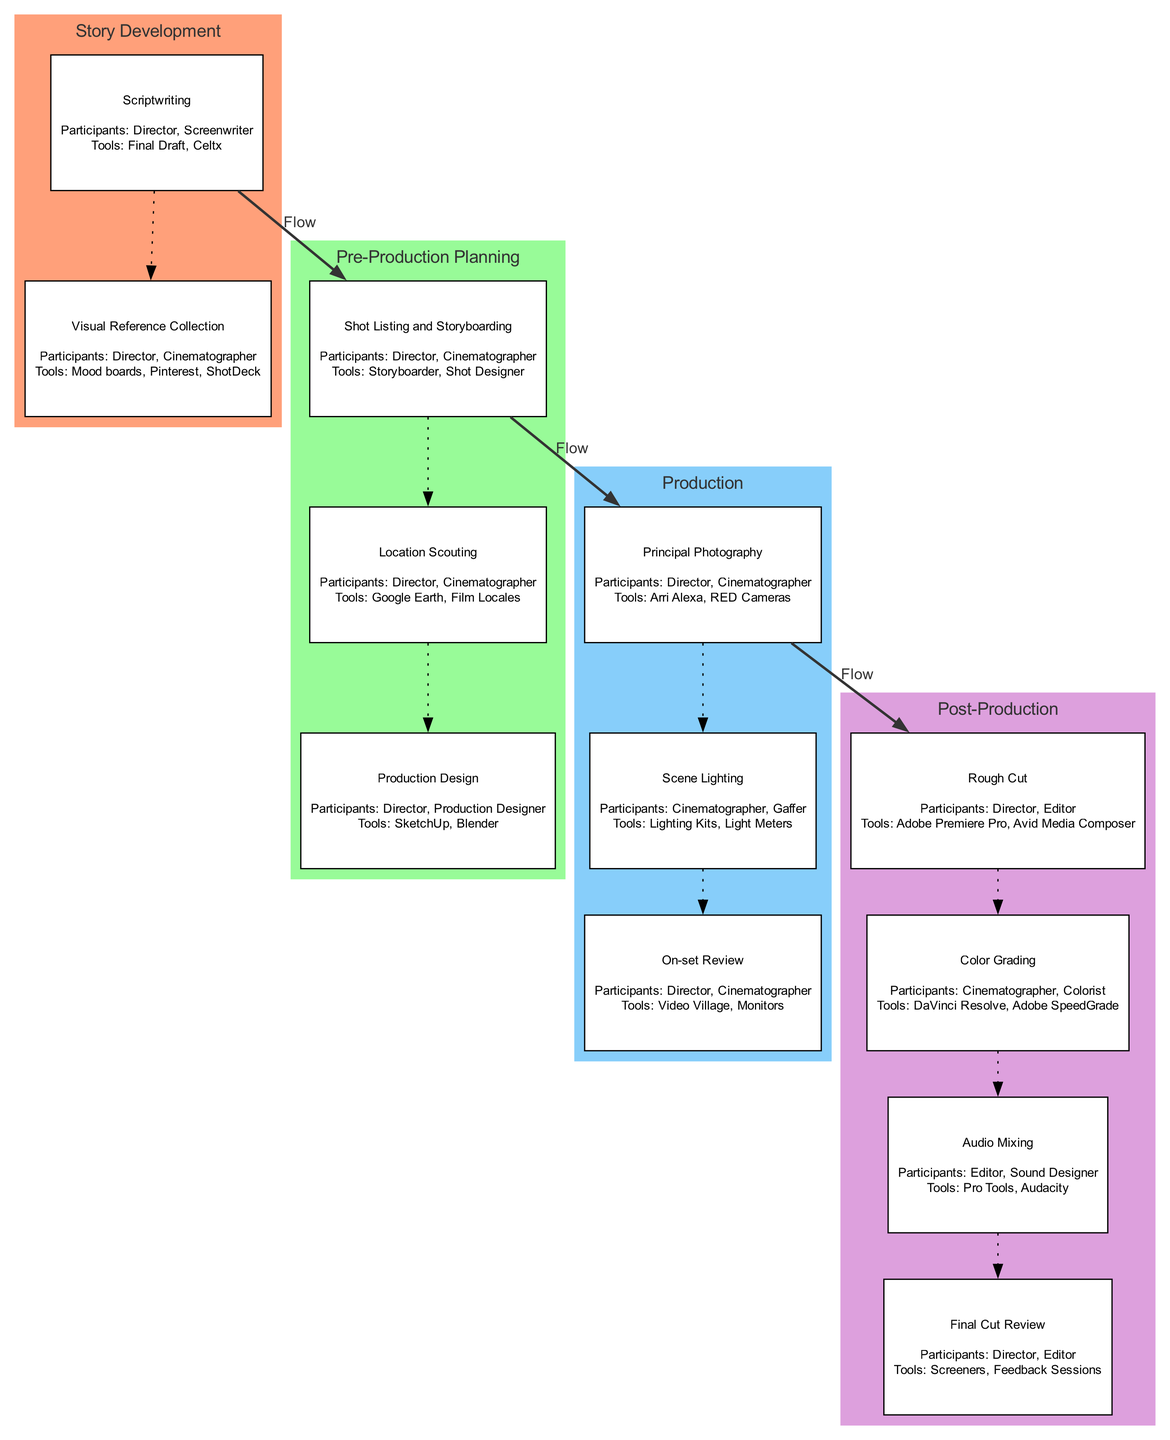What is the first step in the workflow? The first step in the workflow is "Story Development," as it is the initial element listed in the diagram. This indicates that the creative process begins with the conception of the film's narrative and visual language.
Answer: Story Development How many sub-elements are under "Production"? Under the "Production" element, there are three sub-elements listed: "Principal Photography," "Scene Lighting," and "On-set Review." This can be counted directly from the diagram.
Answer: 3 Which participants are involved in "Rough Cut"? The "Rough Cut" sub-element involves two participants: the "Director" and the "Editor," as shown in the diagram under this section.
Answer: Director, Editor What tools are used for "Color Grading"? The tools used for "Color Grading" are "DaVinci Resolve" and "Adobe SpeedGrade," as highlighted in the diagram associated with this sub-element.
Answer: DaVinci Resolve, Adobe SpeedGrade Which two main elements are connected by a bold edge? The elements "Production" and "Post-Production" are connected by a bold edge, indicating a clear flow in the collaboration process. This can be visualized by observing the connections between main elements in the diagram.
Answer: Production, Post-Production What is the main purpose of "Pre-Production Planning"? The purpose of "Pre-Production Planning" is to organize the detailed aspects of each scene, including technical considerations, which is noted in the description of this element in the diagram.
Answer: Detailed planning of each scene How many tools are listed for "Location Scouting"? For "Location Scouting," there are two tools listed: "Google Earth" and "Film Locales," which can be directly referenced from the tools specified in the diagram.
Answer: 2 Which two participants are involved in "On-set Review"? The participants involved in "On-set Review" are the "Director" and the "Cinematographer," as indicated in the associated details of this sub-element on the diagram.
Answer: Director, Cinematographer What is the last step in the workflow? The last step in the workflow is "Post-Production," which is the final main element and indicates the stage where the captured footage is edited and refined.
Answer: Post-Production 